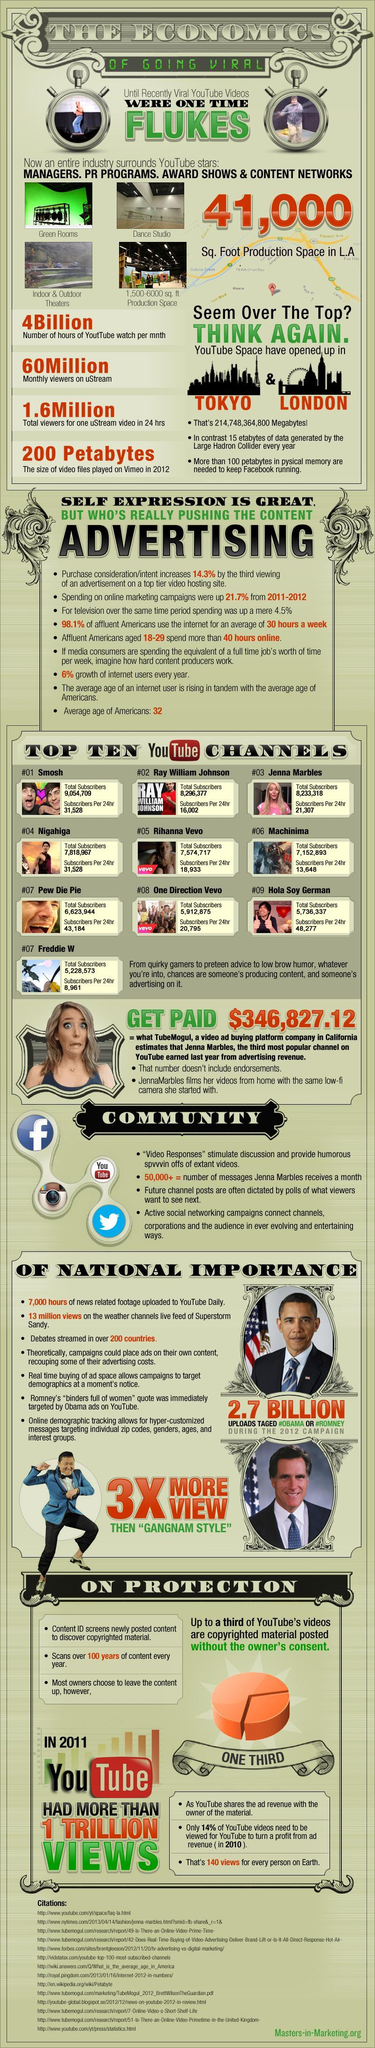What is the total number of subscribers for the third most rated channel in YouTube?
Answer the question with a short phrase. 8,233,318 What is the total number of subscribers for the top most rated channel in YouTube? 9,054,709 What is the monthly viewers in uStream? 60 Million What is the size of video files played on Vimeo in the year 2012? 200 Petabytes How many total number of viewers for one uStream video in 24 hours? 1.6 Million Which is the second most rated YouTube Channel? Ray William Johnson What is the total number of subscribers for the second most rated channel in YouTube? 8,296,377 Which is the third most rated YouTube Channel? Jenna Marbles Which is the top rated YouTube Channel? Smosh What is the number of hours of YouTube watch per month? 4 Billion 